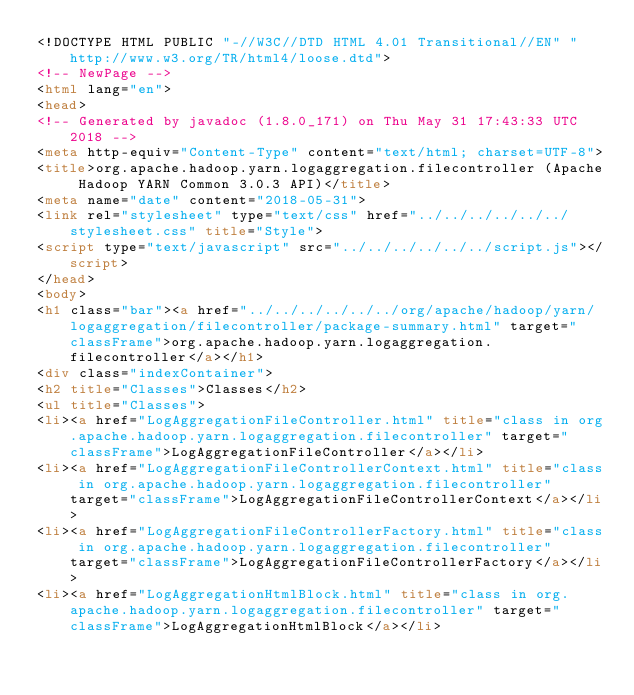<code> <loc_0><loc_0><loc_500><loc_500><_HTML_><!DOCTYPE HTML PUBLIC "-//W3C//DTD HTML 4.01 Transitional//EN" "http://www.w3.org/TR/html4/loose.dtd">
<!-- NewPage -->
<html lang="en">
<head>
<!-- Generated by javadoc (1.8.0_171) on Thu May 31 17:43:33 UTC 2018 -->
<meta http-equiv="Content-Type" content="text/html; charset=UTF-8">
<title>org.apache.hadoop.yarn.logaggregation.filecontroller (Apache Hadoop YARN Common 3.0.3 API)</title>
<meta name="date" content="2018-05-31">
<link rel="stylesheet" type="text/css" href="../../../../../../stylesheet.css" title="Style">
<script type="text/javascript" src="../../../../../../script.js"></script>
</head>
<body>
<h1 class="bar"><a href="../../../../../../org/apache/hadoop/yarn/logaggregation/filecontroller/package-summary.html" target="classFrame">org.apache.hadoop.yarn.logaggregation.filecontroller</a></h1>
<div class="indexContainer">
<h2 title="Classes">Classes</h2>
<ul title="Classes">
<li><a href="LogAggregationFileController.html" title="class in org.apache.hadoop.yarn.logaggregation.filecontroller" target="classFrame">LogAggregationFileController</a></li>
<li><a href="LogAggregationFileControllerContext.html" title="class in org.apache.hadoop.yarn.logaggregation.filecontroller" target="classFrame">LogAggregationFileControllerContext</a></li>
<li><a href="LogAggregationFileControllerFactory.html" title="class in org.apache.hadoop.yarn.logaggregation.filecontroller" target="classFrame">LogAggregationFileControllerFactory</a></li>
<li><a href="LogAggregationHtmlBlock.html" title="class in org.apache.hadoop.yarn.logaggregation.filecontroller" target="classFrame">LogAggregationHtmlBlock</a></li></code> 